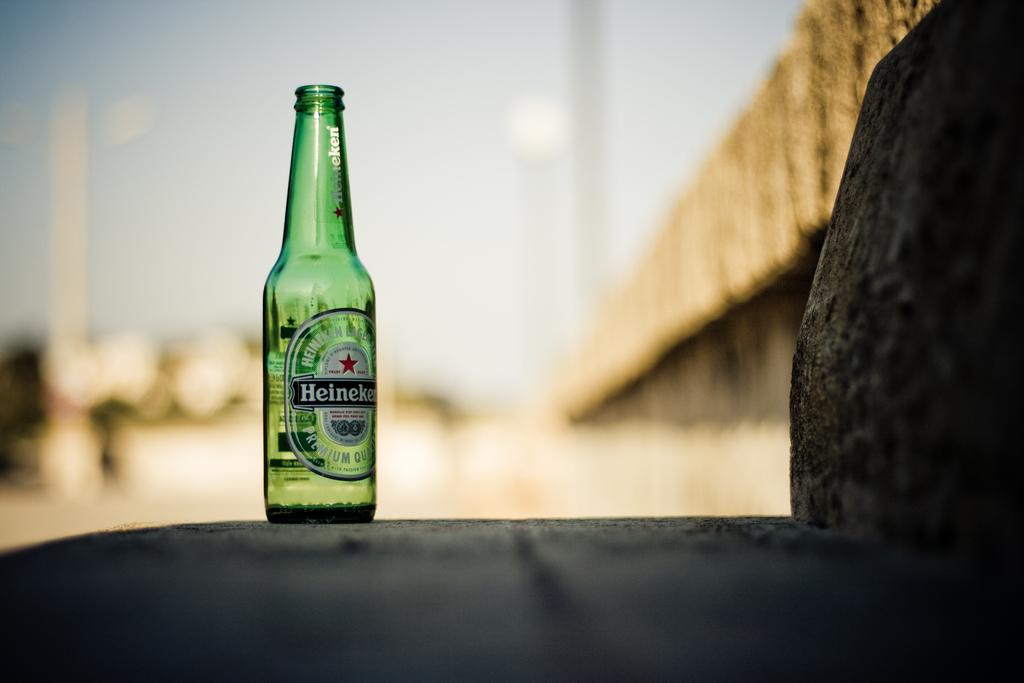Are these premium quality?
Provide a short and direct response. Yes. What is the brand of alcohol seen here?
Make the answer very short. Heineken. 